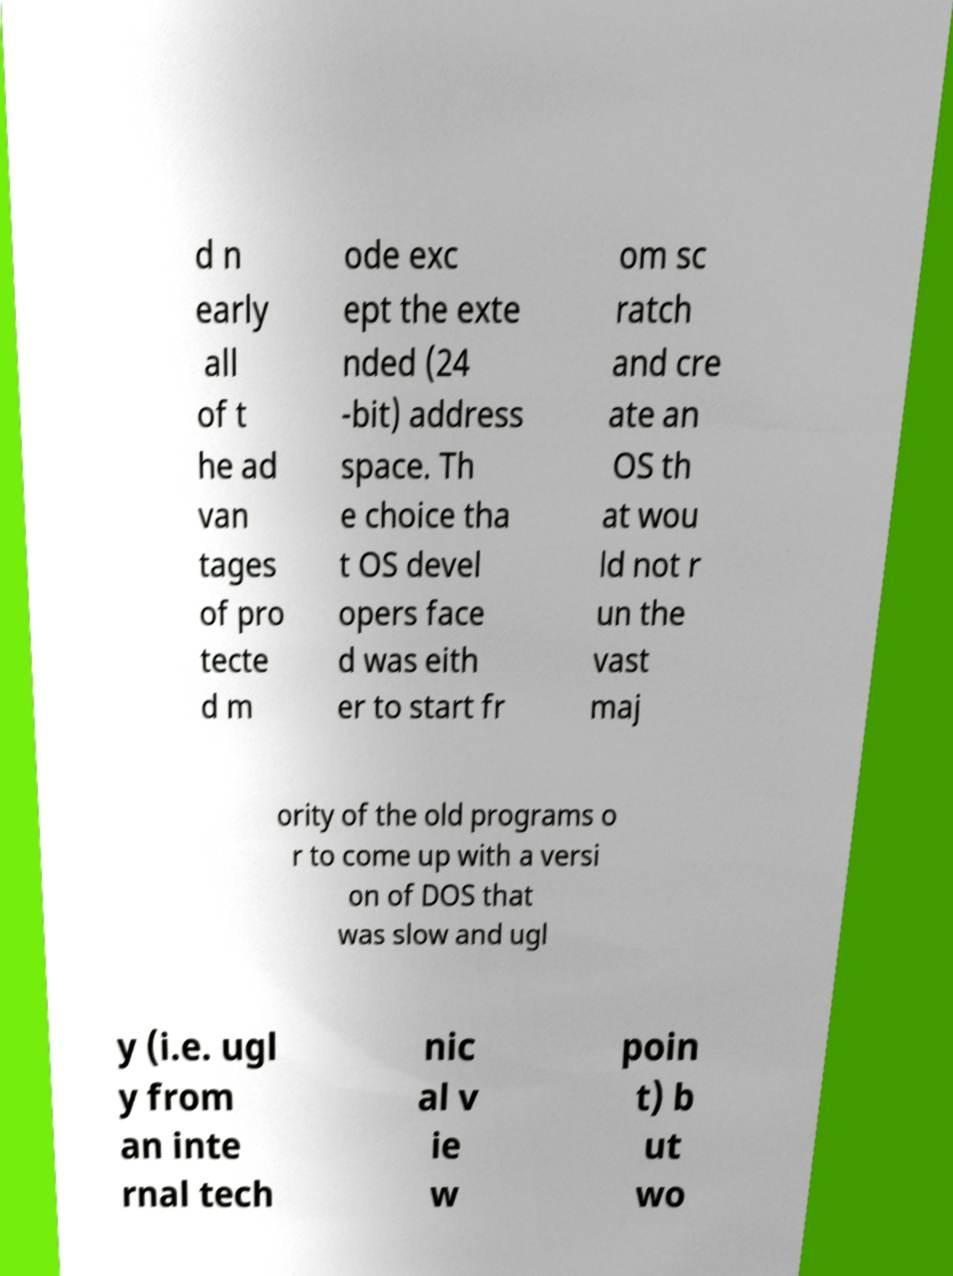Could you extract and type out the text from this image? d n early all of t he ad van tages of pro tecte d m ode exc ept the exte nded (24 -bit) address space. Th e choice tha t OS devel opers face d was eith er to start fr om sc ratch and cre ate an OS th at wou ld not r un the vast maj ority of the old programs o r to come up with a versi on of DOS that was slow and ugl y (i.e. ugl y from an inte rnal tech nic al v ie w poin t) b ut wo 